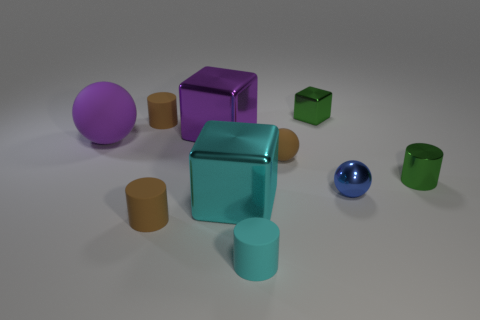There is a brown thing right of the tiny cyan rubber object; is its shape the same as the tiny cyan matte object?
Ensure brevity in your answer.  No. How many matte objects are both behind the large cyan cube and to the right of the cyan block?
Your answer should be compact. 1. What is the color of the large shiny thing on the right side of the shiny block left of the cube that is in front of the purple rubber sphere?
Make the answer very short. Cyan. There is a big purple thing that is right of the large purple sphere; how many tiny green things are behind it?
Your response must be concise. 1. What number of other objects are the same shape as the blue thing?
Your answer should be compact. 2. What number of things are cylinders or matte objects that are right of the big rubber sphere?
Your answer should be very brief. 5. Are there more brown objects that are right of the cyan matte object than large things to the left of the large matte thing?
Provide a succinct answer. Yes. There is a tiny thing that is in front of the tiny brown object in front of the tiny green metallic object in front of the big purple metal object; what shape is it?
Ensure brevity in your answer.  Cylinder. What shape is the tiny brown matte object in front of the small matte object that is on the right side of the tiny cyan rubber cylinder?
Ensure brevity in your answer.  Cylinder. Is there a green cylinder that has the same material as the blue sphere?
Offer a terse response. Yes. 